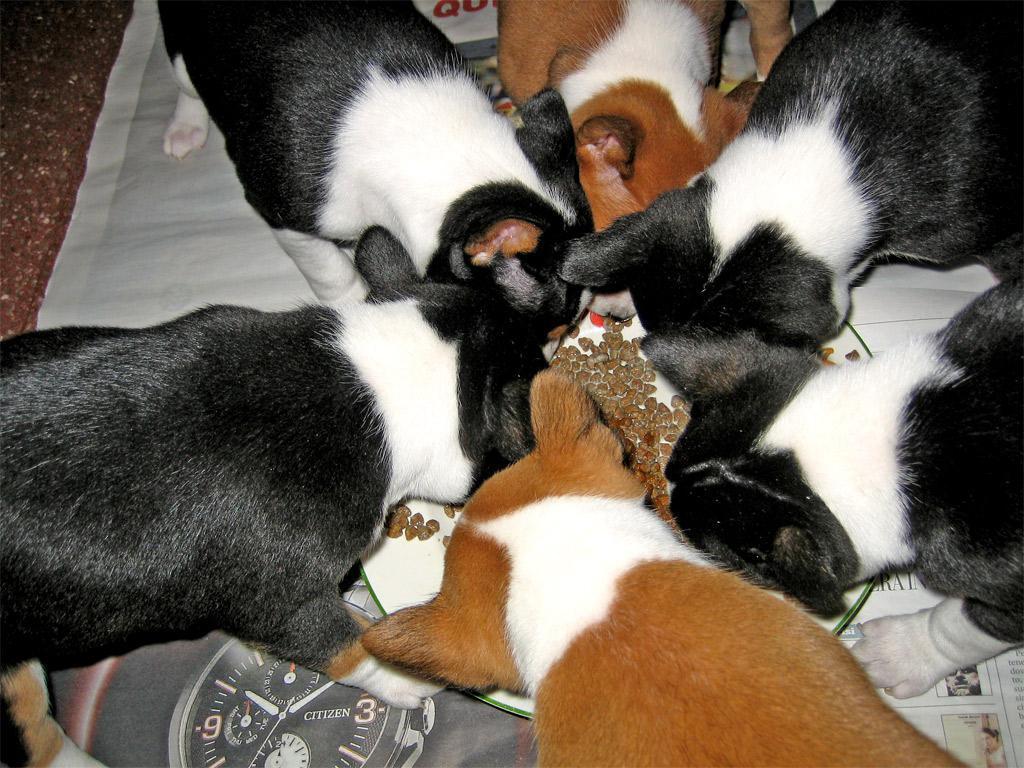In one or two sentences, can you explain what this image depicts? In this image, we can see dogs eating food. 